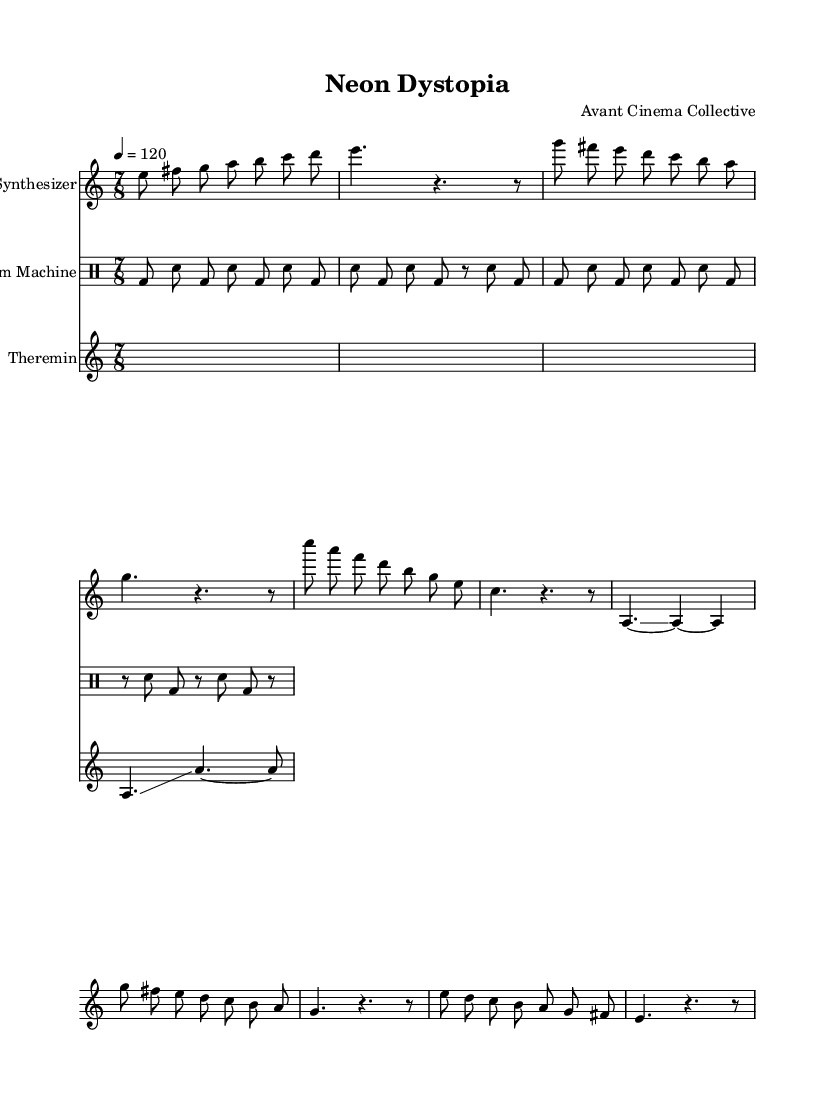What is the time signature of this score? The time signature is indicated at the beginning of the score as 7/8, which specifies that each measure contains seven eighth notes.
Answer: 7/8 What is the tempo marking of the piece? The tempo is notated as "4 = 120", meaning that there are 120 beats per minute with a quarter note receiving one beat.
Answer: 120 Which instrument is playing the intro section? The intro section is notated under the synthesizer staff, indicating that the synthesizer is the instrument for this part.
Answer: Synthesizer How many measures are there in Section A? Section A contains two measures as indicated by the two sets of notation present under the synthesizer staff within the marked section.
Answer: 2 What type of musical device is used to produce glissando effects? The glissando effect is specifically written for the theremin, which is designed for smooth pitch transitions characteristic of many electronic compositions.
Answer: Theremin What rhythmic pattern does the drum machine primarily follow? The drum machine part demonstrates a consistent alternating pattern between bass drum and snare drum for most of its section, showing a repetitive rhythmic structure that is common in electronic music.
Answer: Alternating What is the final melodic note played by the synthesizer in the outro? The final note in the synthesizer's outro is a "fis", which is the seventh note after the note sequence presented at the end of this section.
Answer: F sharp 